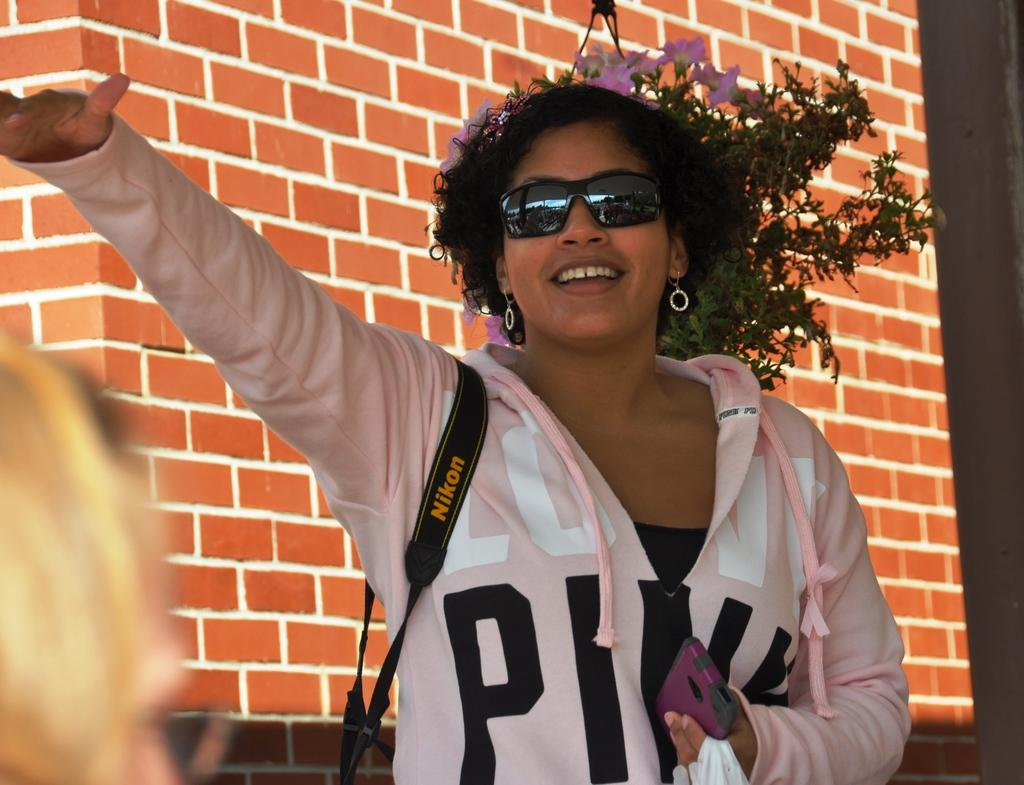What is the main subject of the image? The main subject of the image is a woman. What is the woman wearing in the image? The woman is wearing goggles in the image. What is the woman holding in the image? The woman is holding a mobile and a plastic cover in the image. What can be seen in the background of the image? There is a wall and a plant with flowers in the background of the image. How many divisions are present in the image? There is no mention of divisions in the image, as it features a woman, goggles, a mobile, a plastic cover, a wall, and a plant with flowers. 